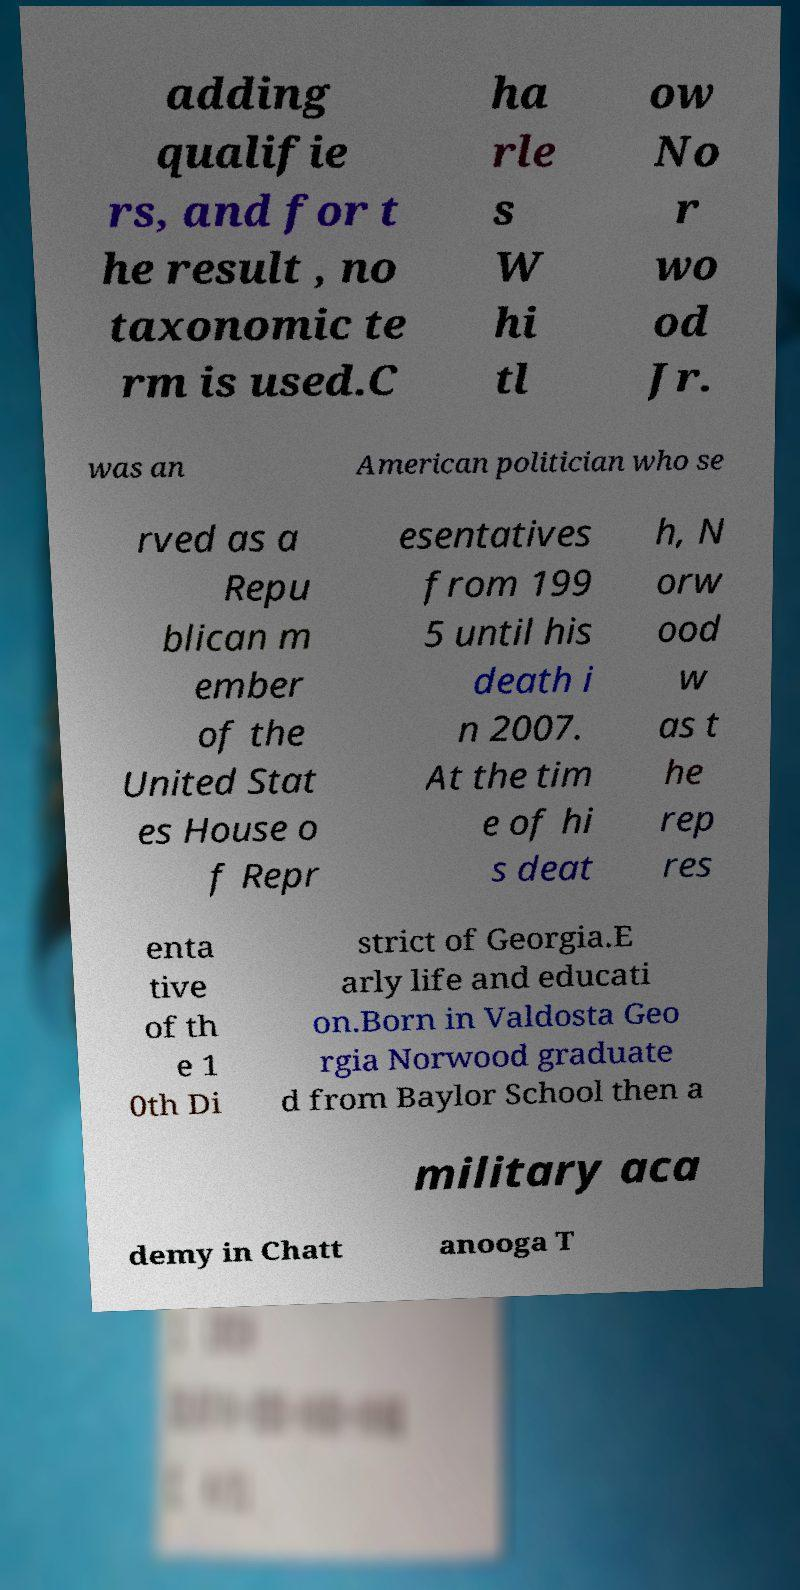There's text embedded in this image that I need extracted. Can you transcribe it verbatim? adding qualifie rs, and for t he result , no taxonomic te rm is used.C ha rle s W hi tl ow No r wo od Jr. was an American politician who se rved as a Repu blican m ember of the United Stat es House o f Repr esentatives from 199 5 until his death i n 2007. At the tim e of hi s deat h, N orw ood w as t he rep res enta tive of th e 1 0th Di strict of Georgia.E arly life and educati on.Born in Valdosta Geo rgia Norwood graduate d from Baylor School then a military aca demy in Chatt anooga T 